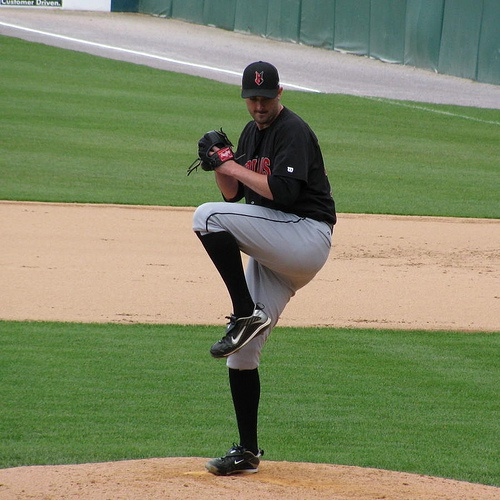Describe the objects in this image and their specific colors. I can see people in gray, black, darkgray, and maroon tones and baseball glove in gray, black, maroon, and brown tones in this image. 